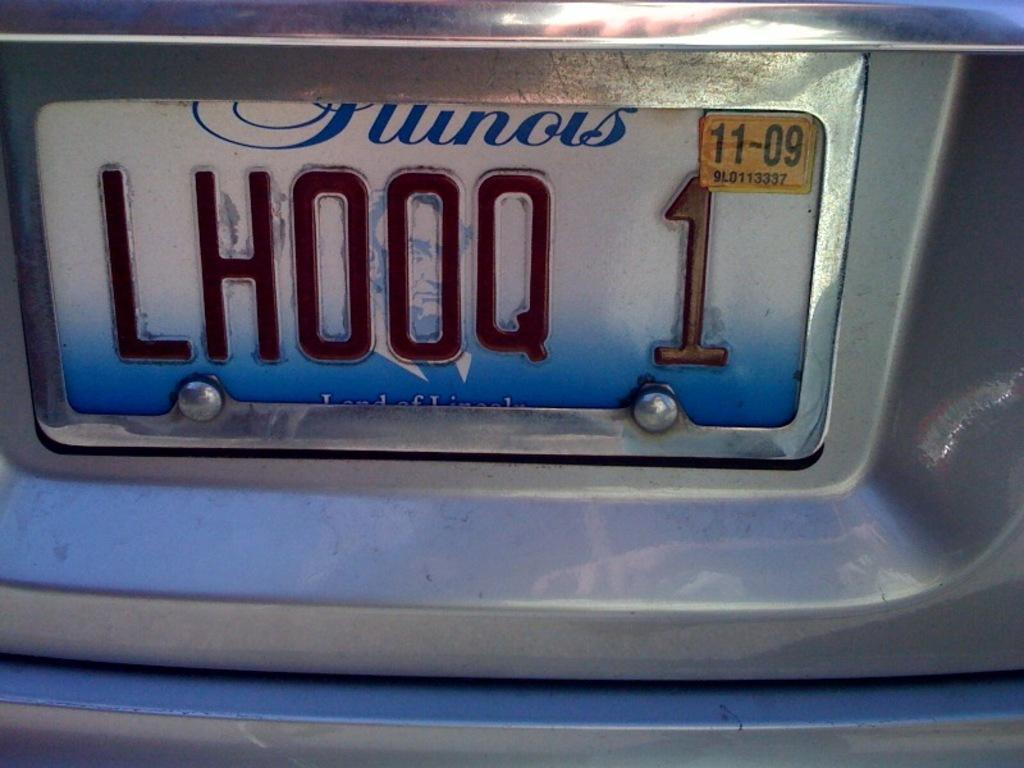Provide a one-sentence caption for the provided image. A license plate with a yellow registraion sticker with expiration date 11-09. 